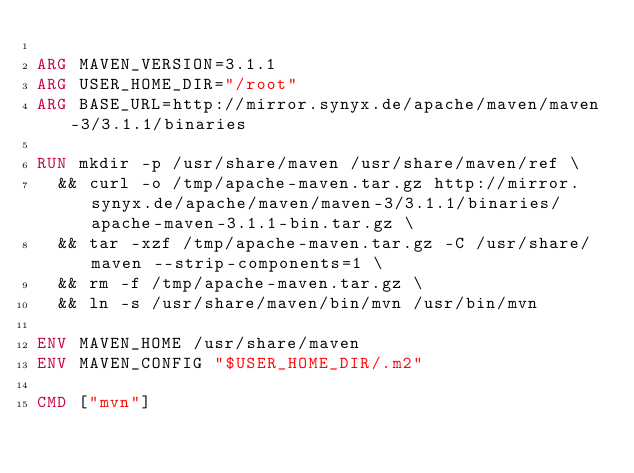<code> <loc_0><loc_0><loc_500><loc_500><_Dockerfile_>
ARG MAVEN_VERSION=3.1.1
ARG USER_HOME_DIR="/root"
ARG BASE_URL=http://mirror.synyx.de/apache/maven/maven-3/3.1.1/binaries

RUN mkdir -p /usr/share/maven /usr/share/maven/ref \
  && curl -o /tmp/apache-maven.tar.gz http://mirror.synyx.de/apache/maven/maven-3/3.1.1/binaries/apache-maven-3.1.1-bin.tar.gz \
  && tar -xzf /tmp/apache-maven.tar.gz -C /usr/share/maven --strip-components=1 \
  && rm -f /tmp/apache-maven.tar.gz \
  && ln -s /usr/share/maven/bin/mvn /usr/bin/mvn

ENV MAVEN_HOME /usr/share/maven
ENV MAVEN_CONFIG "$USER_HOME_DIR/.m2"

CMD ["mvn"]</code> 